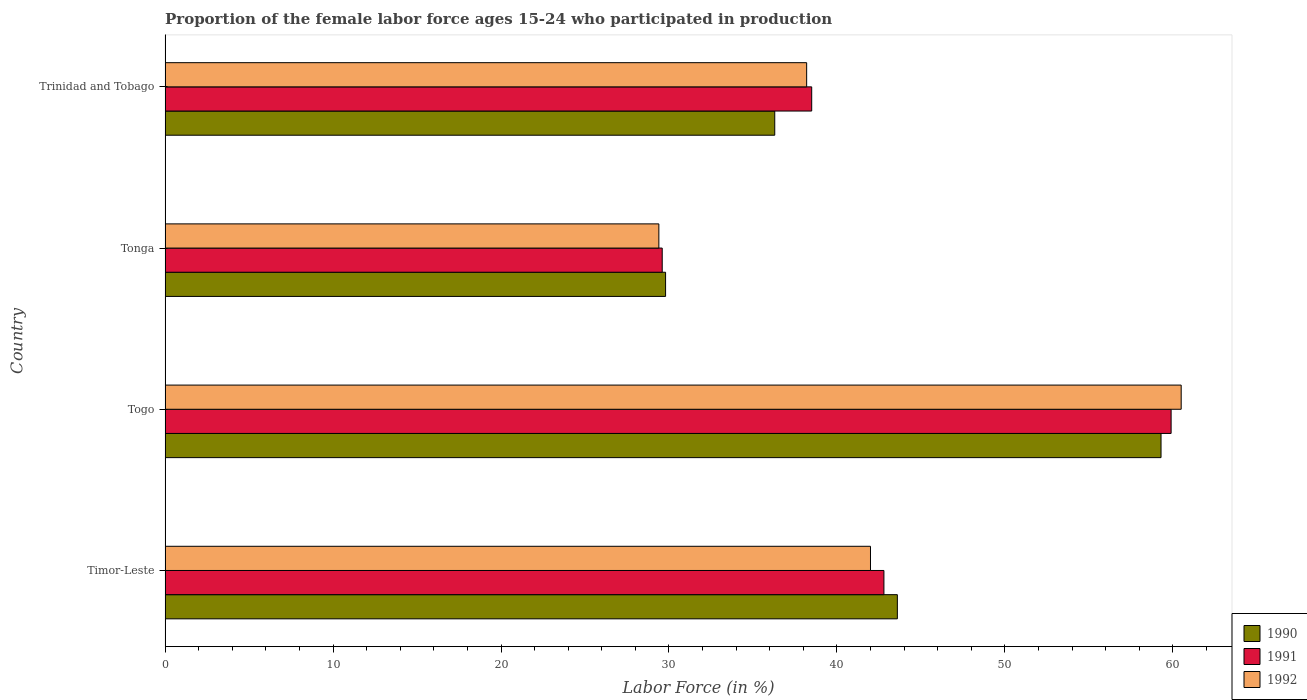How many different coloured bars are there?
Ensure brevity in your answer.  3. How many groups of bars are there?
Offer a terse response. 4. How many bars are there on the 1st tick from the bottom?
Provide a succinct answer. 3. What is the label of the 4th group of bars from the top?
Your answer should be very brief. Timor-Leste. What is the proportion of the female labor force who participated in production in 1991 in Tonga?
Your answer should be very brief. 29.6. Across all countries, what is the maximum proportion of the female labor force who participated in production in 1990?
Provide a short and direct response. 59.3. Across all countries, what is the minimum proportion of the female labor force who participated in production in 1991?
Ensure brevity in your answer.  29.6. In which country was the proportion of the female labor force who participated in production in 1991 maximum?
Your answer should be compact. Togo. In which country was the proportion of the female labor force who participated in production in 1991 minimum?
Keep it short and to the point. Tonga. What is the total proportion of the female labor force who participated in production in 1991 in the graph?
Your answer should be very brief. 170.8. What is the difference between the proportion of the female labor force who participated in production in 1992 in Togo and that in Tonga?
Your answer should be very brief. 31.1. What is the difference between the proportion of the female labor force who participated in production in 1991 in Tonga and the proportion of the female labor force who participated in production in 1992 in Timor-Leste?
Make the answer very short. -12.4. What is the average proportion of the female labor force who participated in production in 1990 per country?
Offer a very short reply. 42.25. What is the difference between the proportion of the female labor force who participated in production in 1992 and proportion of the female labor force who participated in production in 1991 in Trinidad and Tobago?
Keep it short and to the point. -0.3. What is the ratio of the proportion of the female labor force who participated in production in 1991 in Timor-Leste to that in Trinidad and Tobago?
Your response must be concise. 1.11. Is the proportion of the female labor force who participated in production in 1992 in Timor-Leste less than that in Trinidad and Tobago?
Provide a short and direct response. No. Is the difference between the proportion of the female labor force who participated in production in 1992 in Tonga and Trinidad and Tobago greater than the difference between the proportion of the female labor force who participated in production in 1991 in Tonga and Trinidad and Tobago?
Provide a short and direct response. Yes. What is the difference between the highest and the lowest proportion of the female labor force who participated in production in 1992?
Your answer should be compact. 31.1. In how many countries, is the proportion of the female labor force who participated in production in 1992 greater than the average proportion of the female labor force who participated in production in 1992 taken over all countries?
Ensure brevity in your answer.  1. Is the sum of the proportion of the female labor force who participated in production in 1992 in Tonga and Trinidad and Tobago greater than the maximum proportion of the female labor force who participated in production in 1990 across all countries?
Ensure brevity in your answer.  Yes. Are all the bars in the graph horizontal?
Your answer should be very brief. Yes. What is the difference between two consecutive major ticks on the X-axis?
Your answer should be compact. 10. Does the graph contain grids?
Give a very brief answer. No. Where does the legend appear in the graph?
Ensure brevity in your answer.  Bottom right. How many legend labels are there?
Offer a terse response. 3. What is the title of the graph?
Offer a terse response. Proportion of the female labor force ages 15-24 who participated in production. Does "1988" appear as one of the legend labels in the graph?
Ensure brevity in your answer.  No. What is the label or title of the X-axis?
Give a very brief answer. Labor Force (in %). What is the Labor Force (in %) in 1990 in Timor-Leste?
Provide a short and direct response. 43.6. What is the Labor Force (in %) in 1991 in Timor-Leste?
Provide a short and direct response. 42.8. What is the Labor Force (in %) of 1992 in Timor-Leste?
Give a very brief answer. 42. What is the Labor Force (in %) in 1990 in Togo?
Ensure brevity in your answer.  59.3. What is the Labor Force (in %) in 1991 in Togo?
Make the answer very short. 59.9. What is the Labor Force (in %) of 1992 in Togo?
Ensure brevity in your answer.  60.5. What is the Labor Force (in %) of 1990 in Tonga?
Provide a succinct answer. 29.8. What is the Labor Force (in %) of 1991 in Tonga?
Make the answer very short. 29.6. What is the Labor Force (in %) of 1992 in Tonga?
Offer a terse response. 29.4. What is the Labor Force (in %) in 1990 in Trinidad and Tobago?
Provide a succinct answer. 36.3. What is the Labor Force (in %) of 1991 in Trinidad and Tobago?
Keep it short and to the point. 38.5. What is the Labor Force (in %) in 1992 in Trinidad and Tobago?
Your answer should be very brief. 38.2. Across all countries, what is the maximum Labor Force (in %) in 1990?
Make the answer very short. 59.3. Across all countries, what is the maximum Labor Force (in %) in 1991?
Make the answer very short. 59.9. Across all countries, what is the maximum Labor Force (in %) in 1992?
Ensure brevity in your answer.  60.5. Across all countries, what is the minimum Labor Force (in %) of 1990?
Provide a succinct answer. 29.8. Across all countries, what is the minimum Labor Force (in %) in 1991?
Make the answer very short. 29.6. Across all countries, what is the minimum Labor Force (in %) in 1992?
Your answer should be compact. 29.4. What is the total Labor Force (in %) in 1990 in the graph?
Give a very brief answer. 169. What is the total Labor Force (in %) of 1991 in the graph?
Give a very brief answer. 170.8. What is the total Labor Force (in %) in 1992 in the graph?
Provide a succinct answer. 170.1. What is the difference between the Labor Force (in %) in 1990 in Timor-Leste and that in Togo?
Offer a terse response. -15.7. What is the difference between the Labor Force (in %) of 1991 in Timor-Leste and that in Togo?
Offer a terse response. -17.1. What is the difference between the Labor Force (in %) of 1992 in Timor-Leste and that in Togo?
Provide a short and direct response. -18.5. What is the difference between the Labor Force (in %) of 1990 in Timor-Leste and that in Tonga?
Offer a terse response. 13.8. What is the difference between the Labor Force (in %) of 1991 in Timor-Leste and that in Tonga?
Ensure brevity in your answer.  13.2. What is the difference between the Labor Force (in %) in 1992 in Timor-Leste and that in Tonga?
Keep it short and to the point. 12.6. What is the difference between the Labor Force (in %) in 1990 in Timor-Leste and that in Trinidad and Tobago?
Offer a very short reply. 7.3. What is the difference between the Labor Force (in %) of 1991 in Timor-Leste and that in Trinidad and Tobago?
Your answer should be compact. 4.3. What is the difference between the Labor Force (in %) of 1990 in Togo and that in Tonga?
Provide a succinct answer. 29.5. What is the difference between the Labor Force (in %) in 1991 in Togo and that in Tonga?
Your answer should be very brief. 30.3. What is the difference between the Labor Force (in %) of 1992 in Togo and that in Tonga?
Ensure brevity in your answer.  31.1. What is the difference between the Labor Force (in %) of 1991 in Togo and that in Trinidad and Tobago?
Your answer should be compact. 21.4. What is the difference between the Labor Force (in %) in 1992 in Togo and that in Trinidad and Tobago?
Your response must be concise. 22.3. What is the difference between the Labor Force (in %) of 1990 in Tonga and that in Trinidad and Tobago?
Make the answer very short. -6.5. What is the difference between the Labor Force (in %) of 1991 in Tonga and that in Trinidad and Tobago?
Provide a succinct answer. -8.9. What is the difference between the Labor Force (in %) in 1992 in Tonga and that in Trinidad and Tobago?
Your answer should be compact. -8.8. What is the difference between the Labor Force (in %) of 1990 in Timor-Leste and the Labor Force (in %) of 1991 in Togo?
Your response must be concise. -16.3. What is the difference between the Labor Force (in %) of 1990 in Timor-Leste and the Labor Force (in %) of 1992 in Togo?
Offer a terse response. -16.9. What is the difference between the Labor Force (in %) of 1991 in Timor-Leste and the Labor Force (in %) of 1992 in Togo?
Provide a succinct answer. -17.7. What is the difference between the Labor Force (in %) of 1991 in Timor-Leste and the Labor Force (in %) of 1992 in Tonga?
Make the answer very short. 13.4. What is the difference between the Labor Force (in %) in 1990 in Timor-Leste and the Labor Force (in %) in 1991 in Trinidad and Tobago?
Make the answer very short. 5.1. What is the difference between the Labor Force (in %) of 1990 in Timor-Leste and the Labor Force (in %) of 1992 in Trinidad and Tobago?
Make the answer very short. 5.4. What is the difference between the Labor Force (in %) in 1990 in Togo and the Labor Force (in %) in 1991 in Tonga?
Keep it short and to the point. 29.7. What is the difference between the Labor Force (in %) of 1990 in Togo and the Labor Force (in %) of 1992 in Tonga?
Offer a terse response. 29.9. What is the difference between the Labor Force (in %) in 1991 in Togo and the Labor Force (in %) in 1992 in Tonga?
Provide a short and direct response. 30.5. What is the difference between the Labor Force (in %) in 1990 in Togo and the Labor Force (in %) in 1991 in Trinidad and Tobago?
Make the answer very short. 20.8. What is the difference between the Labor Force (in %) of 1990 in Togo and the Labor Force (in %) of 1992 in Trinidad and Tobago?
Make the answer very short. 21.1. What is the difference between the Labor Force (in %) of 1991 in Togo and the Labor Force (in %) of 1992 in Trinidad and Tobago?
Your answer should be very brief. 21.7. What is the difference between the Labor Force (in %) of 1990 in Tonga and the Labor Force (in %) of 1991 in Trinidad and Tobago?
Keep it short and to the point. -8.7. What is the difference between the Labor Force (in %) of 1990 in Tonga and the Labor Force (in %) of 1992 in Trinidad and Tobago?
Keep it short and to the point. -8.4. What is the average Labor Force (in %) of 1990 per country?
Make the answer very short. 42.25. What is the average Labor Force (in %) of 1991 per country?
Your answer should be compact. 42.7. What is the average Labor Force (in %) in 1992 per country?
Your answer should be compact. 42.52. What is the difference between the Labor Force (in %) in 1990 and Labor Force (in %) in 1992 in Timor-Leste?
Give a very brief answer. 1.6. What is the difference between the Labor Force (in %) of 1990 and Labor Force (in %) of 1991 in Togo?
Give a very brief answer. -0.6. What is the difference between the Labor Force (in %) in 1990 and Labor Force (in %) in 1991 in Tonga?
Provide a succinct answer. 0.2. What is the difference between the Labor Force (in %) of 1990 and Labor Force (in %) of 1992 in Trinidad and Tobago?
Ensure brevity in your answer.  -1.9. What is the ratio of the Labor Force (in %) in 1990 in Timor-Leste to that in Togo?
Offer a terse response. 0.74. What is the ratio of the Labor Force (in %) in 1991 in Timor-Leste to that in Togo?
Your answer should be very brief. 0.71. What is the ratio of the Labor Force (in %) in 1992 in Timor-Leste to that in Togo?
Provide a short and direct response. 0.69. What is the ratio of the Labor Force (in %) of 1990 in Timor-Leste to that in Tonga?
Your answer should be very brief. 1.46. What is the ratio of the Labor Force (in %) of 1991 in Timor-Leste to that in Tonga?
Your answer should be compact. 1.45. What is the ratio of the Labor Force (in %) of 1992 in Timor-Leste to that in Tonga?
Ensure brevity in your answer.  1.43. What is the ratio of the Labor Force (in %) of 1990 in Timor-Leste to that in Trinidad and Tobago?
Provide a short and direct response. 1.2. What is the ratio of the Labor Force (in %) in 1991 in Timor-Leste to that in Trinidad and Tobago?
Make the answer very short. 1.11. What is the ratio of the Labor Force (in %) in 1992 in Timor-Leste to that in Trinidad and Tobago?
Provide a short and direct response. 1.1. What is the ratio of the Labor Force (in %) of 1990 in Togo to that in Tonga?
Ensure brevity in your answer.  1.99. What is the ratio of the Labor Force (in %) of 1991 in Togo to that in Tonga?
Offer a terse response. 2.02. What is the ratio of the Labor Force (in %) of 1992 in Togo to that in Tonga?
Your answer should be very brief. 2.06. What is the ratio of the Labor Force (in %) in 1990 in Togo to that in Trinidad and Tobago?
Your response must be concise. 1.63. What is the ratio of the Labor Force (in %) of 1991 in Togo to that in Trinidad and Tobago?
Your answer should be compact. 1.56. What is the ratio of the Labor Force (in %) in 1992 in Togo to that in Trinidad and Tobago?
Give a very brief answer. 1.58. What is the ratio of the Labor Force (in %) in 1990 in Tonga to that in Trinidad and Tobago?
Keep it short and to the point. 0.82. What is the ratio of the Labor Force (in %) in 1991 in Tonga to that in Trinidad and Tobago?
Your answer should be compact. 0.77. What is the ratio of the Labor Force (in %) in 1992 in Tonga to that in Trinidad and Tobago?
Offer a very short reply. 0.77. What is the difference between the highest and the second highest Labor Force (in %) in 1990?
Make the answer very short. 15.7. What is the difference between the highest and the second highest Labor Force (in %) of 1991?
Provide a succinct answer. 17.1. What is the difference between the highest and the lowest Labor Force (in %) in 1990?
Provide a short and direct response. 29.5. What is the difference between the highest and the lowest Labor Force (in %) in 1991?
Keep it short and to the point. 30.3. What is the difference between the highest and the lowest Labor Force (in %) of 1992?
Provide a short and direct response. 31.1. 